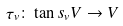<formula> <loc_0><loc_0><loc_500><loc_500>\tau _ { v } \colon \tan s _ { v } V \to V</formula> 